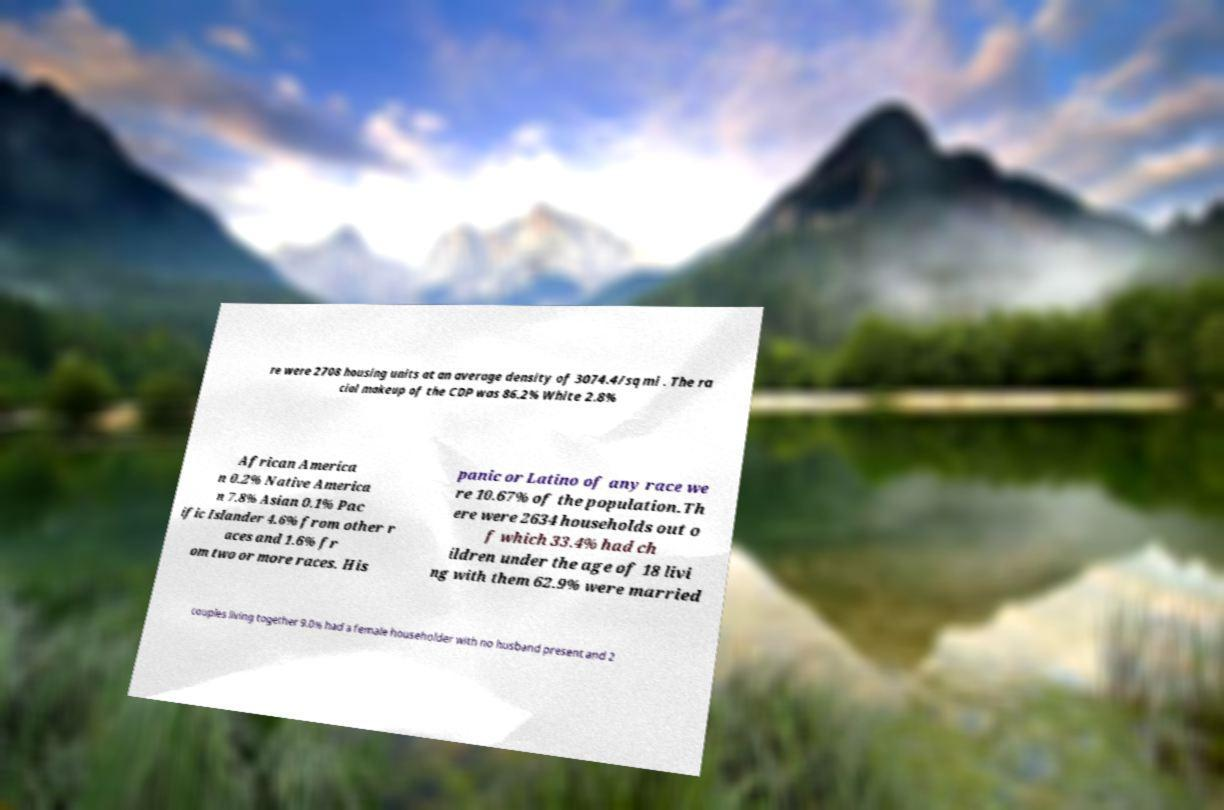Can you accurately transcribe the text from the provided image for me? re were 2708 housing units at an average density of 3074.4/sq mi . The ra cial makeup of the CDP was 86.2% White 2.8% African America n 0.2% Native America n 7.8% Asian 0.1% Pac ific Islander 4.6% from other r aces and 1.6% fr om two or more races. His panic or Latino of any race we re 10.67% of the population.Th ere were 2634 households out o f which 33.4% had ch ildren under the age of 18 livi ng with them 62.9% were married couples living together 9.0% had a female householder with no husband present and 2 